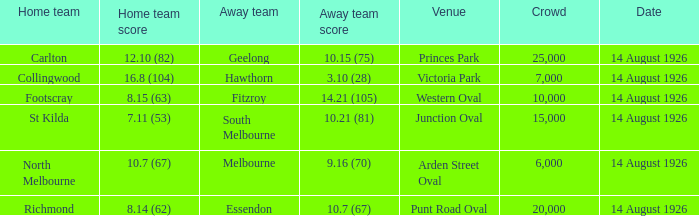What was the extent of the largest gathering essendon participated in as the away team? 20000.0. 